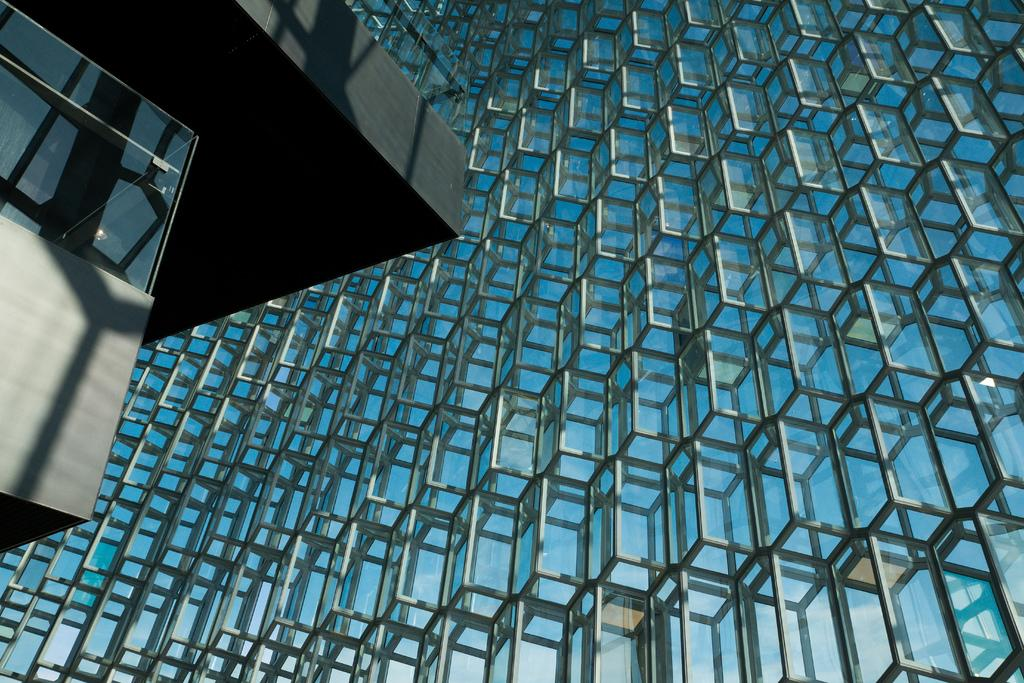What is the main subject of the image? The main subject of the image is a building. What can be seen on the surface of the building? There is a reflection of the sky on the building. Can you describe any specific features of the building? There is a light bulb visible behind a window on the left side of the image. What type of house is being discussed in the image? The image does not depict a house; it is a picture of a building. What reason might the people in the building have for turning on the light bulb? The image does not provide any information about the people in the building or their reasons for turning on the light bulb. 